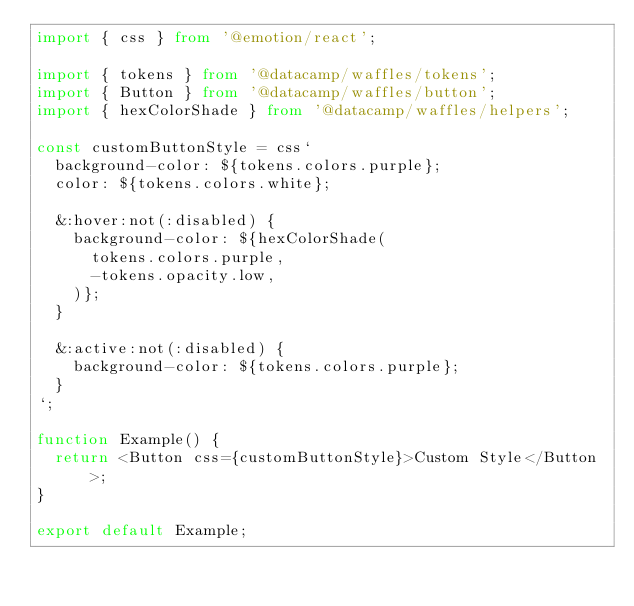Convert code to text. <code><loc_0><loc_0><loc_500><loc_500><_TypeScript_>import { css } from '@emotion/react';

import { tokens } from '@datacamp/waffles/tokens';
import { Button } from '@datacamp/waffles/button';
import { hexColorShade } from '@datacamp/waffles/helpers';

const customButtonStyle = css`
  background-color: ${tokens.colors.purple};
  color: ${tokens.colors.white};

  &:hover:not(:disabled) {
    background-color: ${hexColorShade(
      tokens.colors.purple,
      -tokens.opacity.low,
    )};
  }

  &:active:not(:disabled) {
    background-color: ${tokens.colors.purple};
  }
`;

function Example() {
  return <Button css={customButtonStyle}>Custom Style</Button>;
}

export default Example;
</code> 